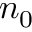<formula> <loc_0><loc_0><loc_500><loc_500>n _ { 0 }</formula> 